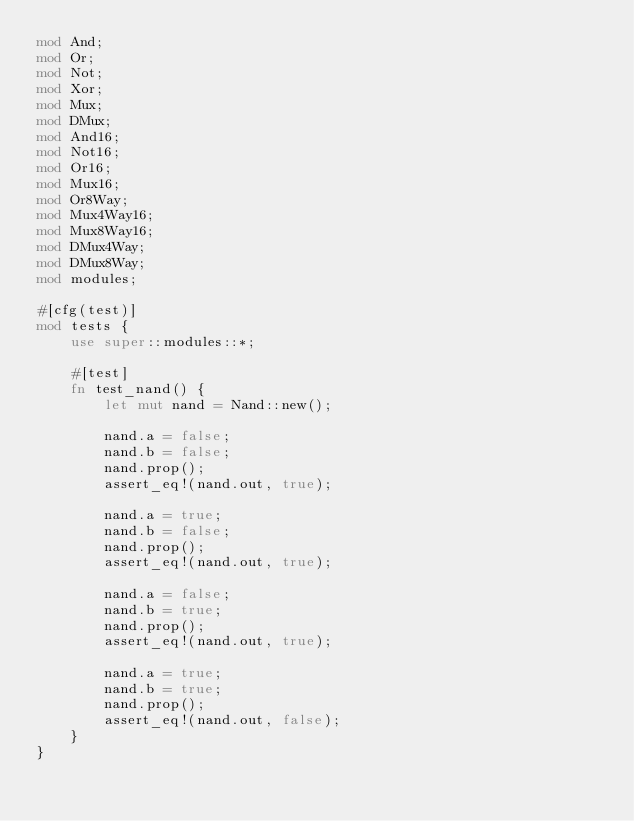Convert code to text. <code><loc_0><loc_0><loc_500><loc_500><_Rust_>mod And;
mod Or;
mod Not;
mod Xor;
mod Mux;
mod DMux;
mod And16;
mod Not16;
mod Or16;
mod Mux16;
mod Or8Way;
mod Mux4Way16;
mod Mux8Way16;
mod DMux4Way;
mod DMux8Way;
mod modules;

#[cfg(test)]
mod tests {
    use super::modules::*;

    #[test]
    fn test_nand() {
        let mut nand = Nand::new();

        nand.a = false;
        nand.b = false;
        nand.prop();
        assert_eq!(nand.out, true);

        nand.a = true;
        nand.b = false;
        nand.prop();
        assert_eq!(nand.out, true);

        nand.a = false;
        nand.b = true;
        nand.prop();
        assert_eq!(nand.out, true);

        nand.a = true;
        nand.b = true;
        nand.prop();
        assert_eq!(nand.out, false);
    }
}
</code> 